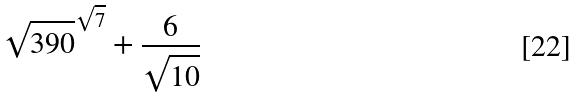Convert formula to latex. <formula><loc_0><loc_0><loc_500><loc_500>\sqrt { 3 9 0 } ^ { \sqrt { 7 } } + \frac { 6 } { \sqrt { 1 0 } }</formula> 